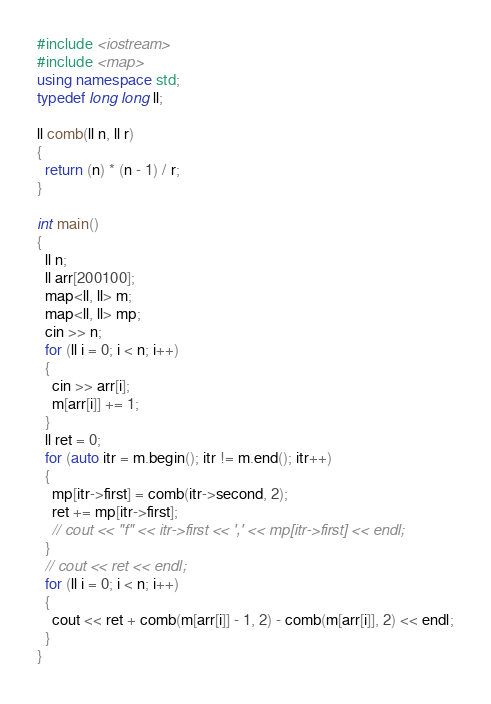<code> <loc_0><loc_0><loc_500><loc_500><_C++_>#include <iostream>
#include <map>
using namespace std;
typedef long long ll;

ll comb(ll n, ll r)
{
  return (n) * (n - 1) / r;
}

int main()
{
  ll n;
  ll arr[200100];
  map<ll, ll> m;
  map<ll, ll> mp;
  cin >> n;
  for (ll i = 0; i < n; i++)
  {
    cin >> arr[i];
    m[arr[i]] += 1;
  }
  ll ret = 0;
  for (auto itr = m.begin(); itr != m.end(); itr++)
  {
    mp[itr->first] = comb(itr->second, 2);
    ret += mp[itr->first];
    // cout << "f" << itr->first << ',' << mp[itr->first] << endl;
  }
  // cout << ret << endl;
  for (ll i = 0; i < n; i++)
  {
    cout << ret + comb(m[arr[i]] - 1, 2) - comb(m[arr[i]], 2) << endl;
  }
}</code> 